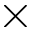Convert formula to latex. <formula><loc_0><loc_0><loc_500><loc_500>\times</formula> 